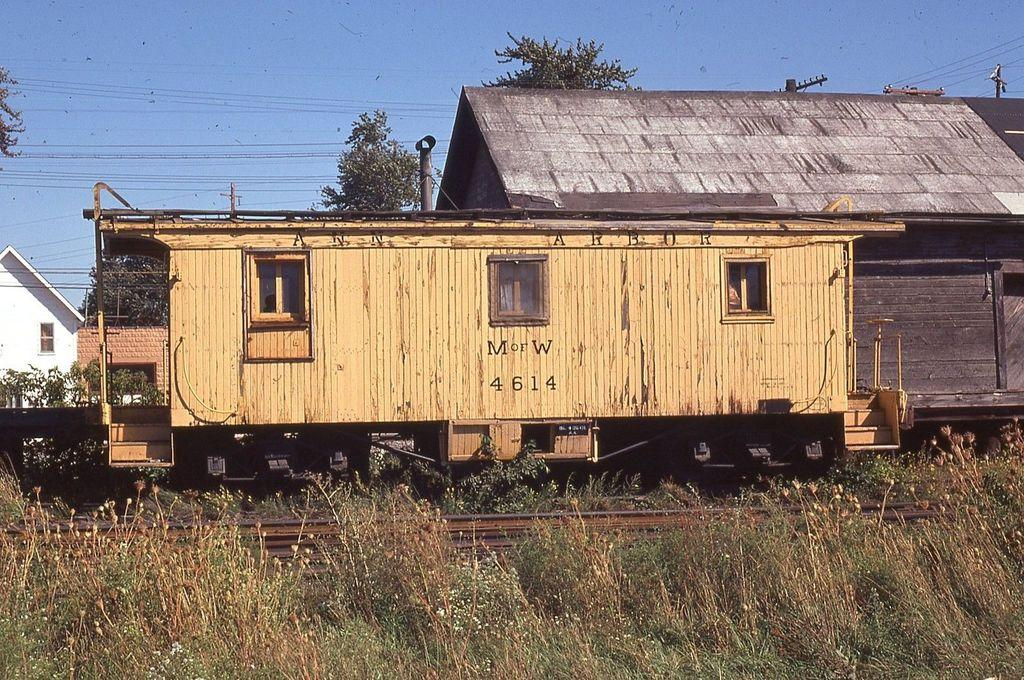What type of living organisms can be seen in the image? Plants and trees are visible in the image. What type of transportation infrastructure is present in the image? There is a railway track and a train in the image. What type of structure can be seen in the image? There is a house in the image. What type of architectural features are present in the image? There are windows, poles, and wires in the image. What is visible in the background of the image? The sky is visible in the background of the image. What type of pan is being used to balance the train in the image? There is no pan present in the image, nor is the train being balanced. 